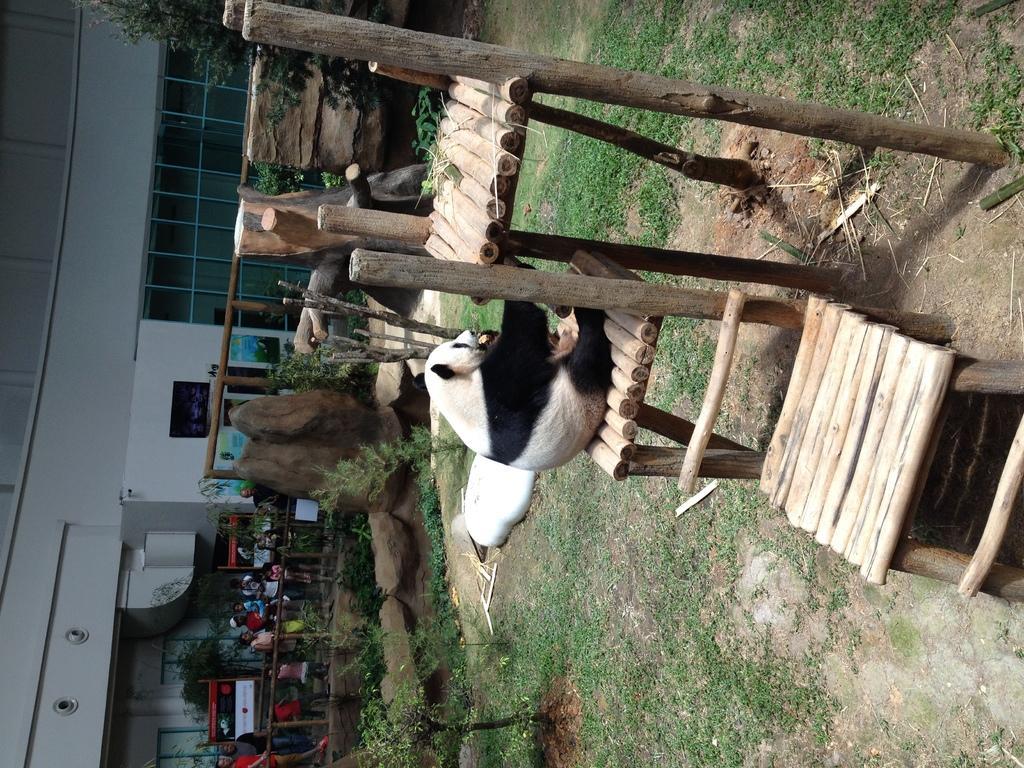Describe this image in one or two sentences. In the middle I can see a polar bear is sitting on a wooden stool and one polar bear is lying on grass, wooden sticks and houseplants. In the background I can see a crowd on the road, fence, stones, metal rods, building, trees and a board. This image is taken may be during a day. 